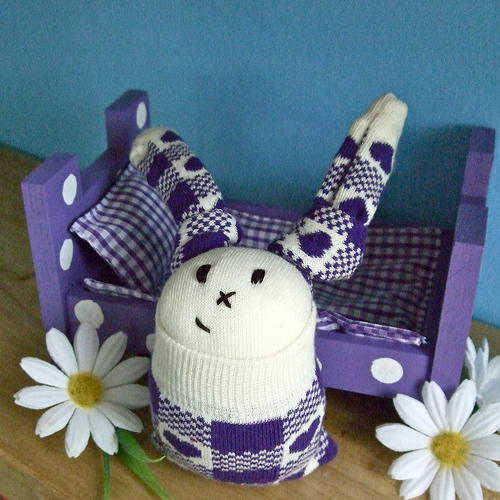<image>
Is there a pillow on the bed? Yes. Looking at the image, I can see the pillow is positioned on top of the bed, with the bed providing support. 